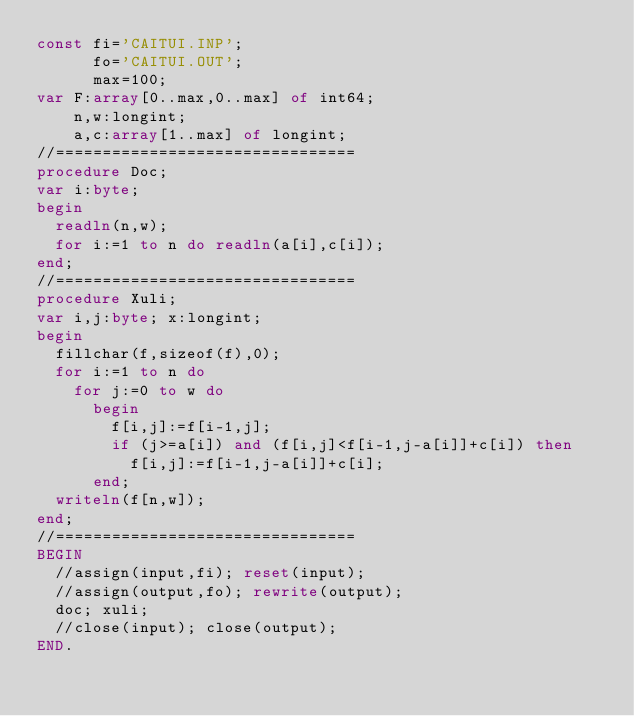<code> <loc_0><loc_0><loc_500><loc_500><_Pascal_>const fi='CAITUI.INP';
      fo='CAITUI.OUT';
      max=100;
var F:array[0..max,0..max] of int64;
    n,w:longint;
    a,c:array[1..max] of longint;
//================================
procedure Doc;
var i:byte;
begin
  readln(n,w);
  for i:=1 to n do readln(a[i],c[i]);
end;
//================================
procedure Xuli;
var i,j:byte; x:longint;
begin
  fillchar(f,sizeof(f),0);
  for i:=1 to n do
    for j:=0 to w do
      begin
        f[i,j]:=f[i-1,j];
        if (j>=a[i]) and (f[i,j]<f[i-1,j-a[i]]+c[i]) then
          f[i,j]:=f[i-1,j-a[i]]+c[i];
      end;
  writeln(f[n,w]);
end;
//================================
BEGIN
  //assign(input,fi); reset(input);
  //assign(output,fo); rewrite(output);
  doc; xuli;
  //close(input); close(output);
END.</code> 